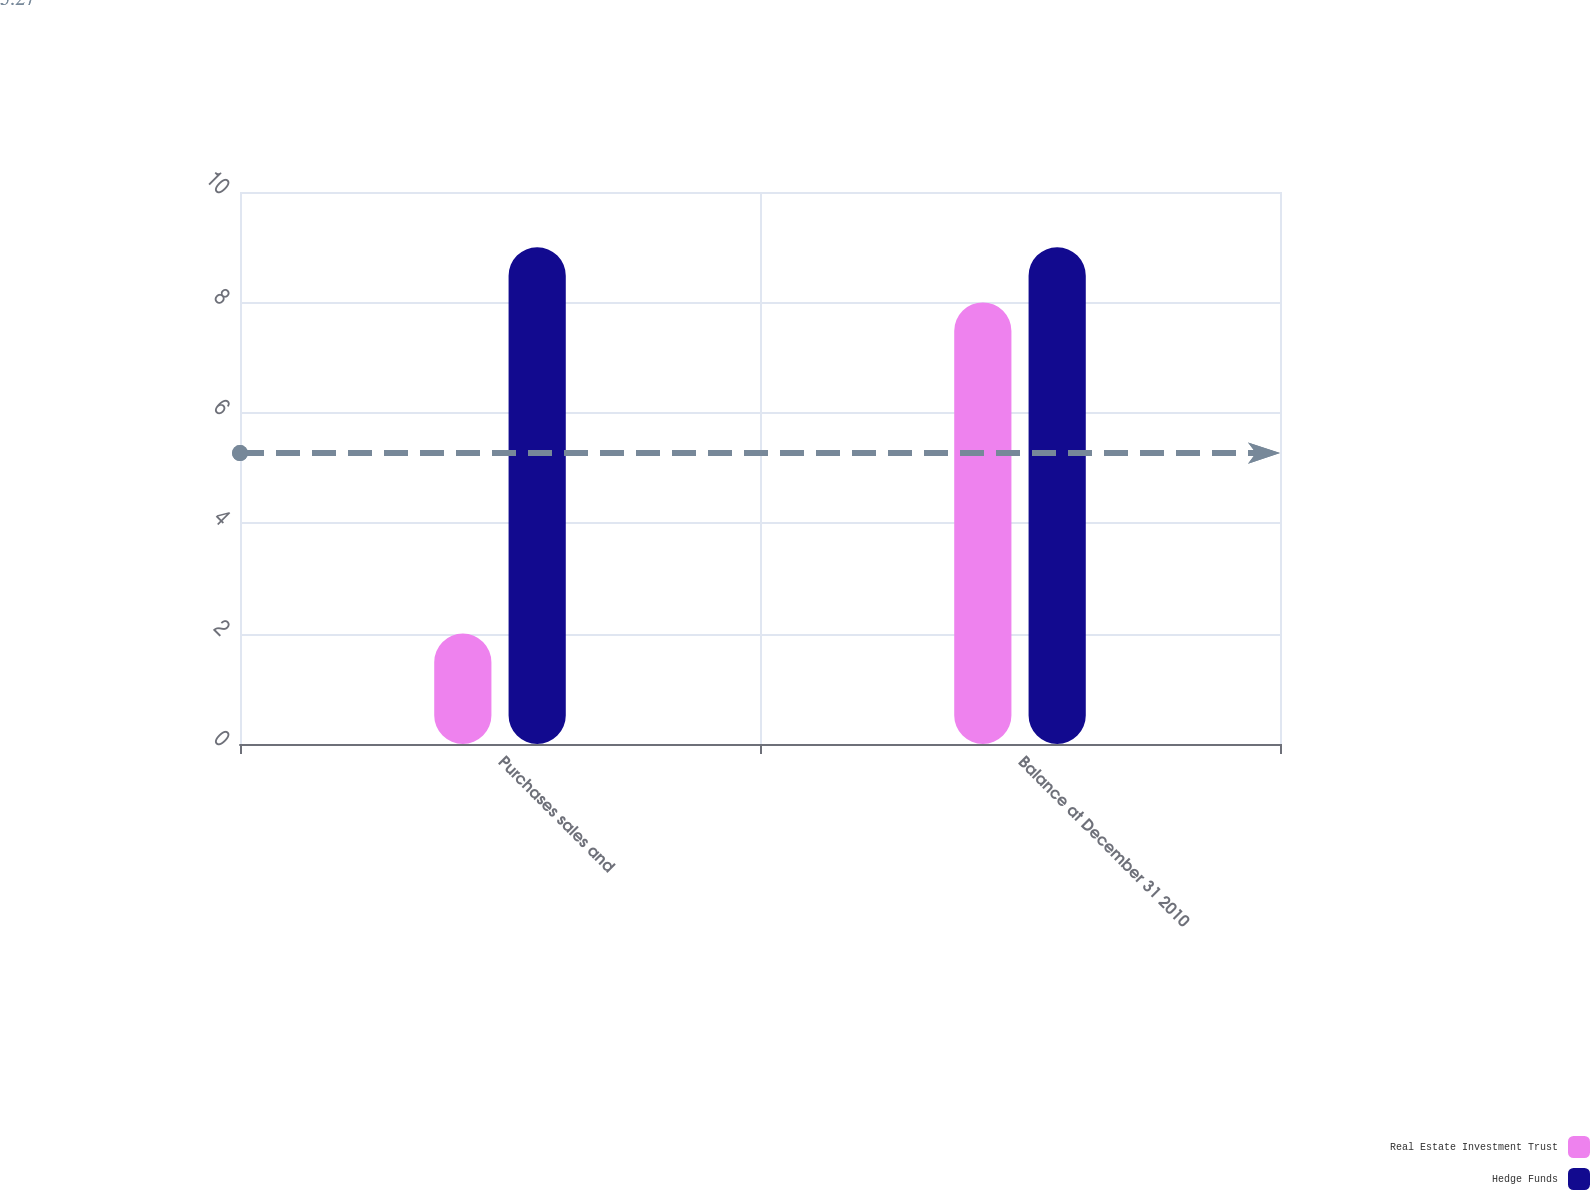Convert chart. <chart><loc_0><loc_0><loc_500><loc_500><stacked_bar_chart><ecel><fcel>Purchases sales and<fcel>Balance at December 31 2010<nl><fcel>Real Estate Investment Trust<fcel>2<fcel>8<nl><fcel>Hedge Funds<fcel>9<fcel>9<nl></chart> 